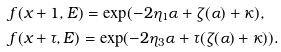Convert formula to latex. <formula><loc_0><loc_0><loc_500><loc_500>& f ( x + 1 , E ) = \exp ( - 2 \eta _ { 1 } \alpha + \zeta ( \alpha ) + \kappa ) , \\ & f ( x + \tau , E ) = \exp ( - 2 \eta _ { 3 } \alpha + \tau ( \zeta ( \alpha ) + \kappa ) ) .</formula> 